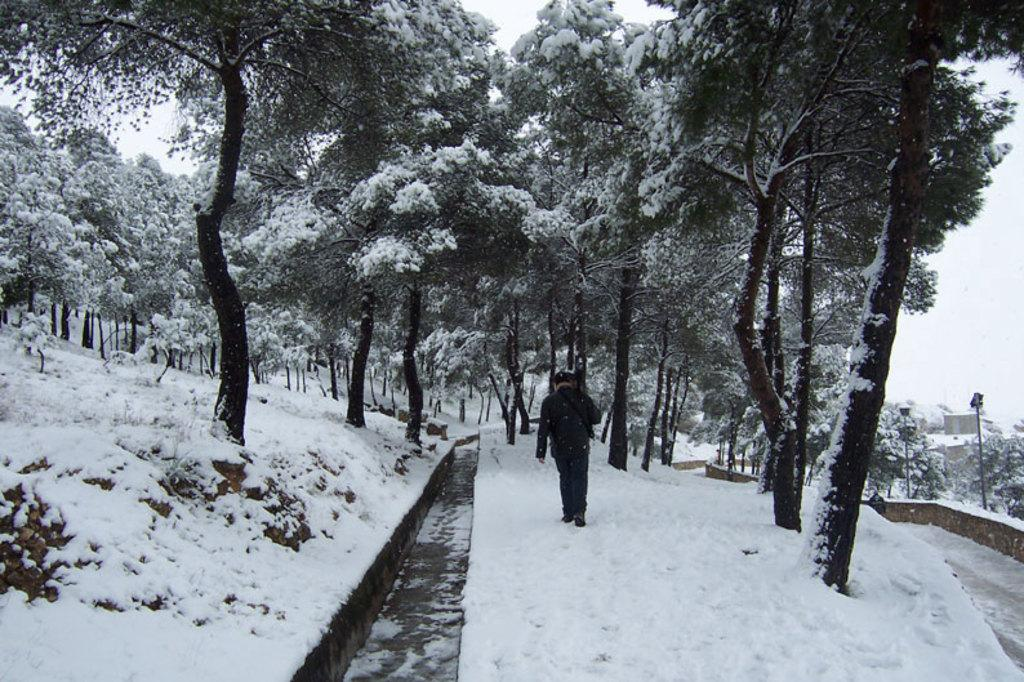What is the main subject of the image? There is a man standing in the image. What is the condition of the ground in the image? The ground is covered with snow. What type of vegetation is present in the image? There are trees in the image. How are the trees affected by the snow? The trees are covered with snow. Can you tell me how much milk the man is holding in the image? There is no milk present in the image; the man is not holding any milk. Are there any horses visible in the image? There are no horses present in the image. 